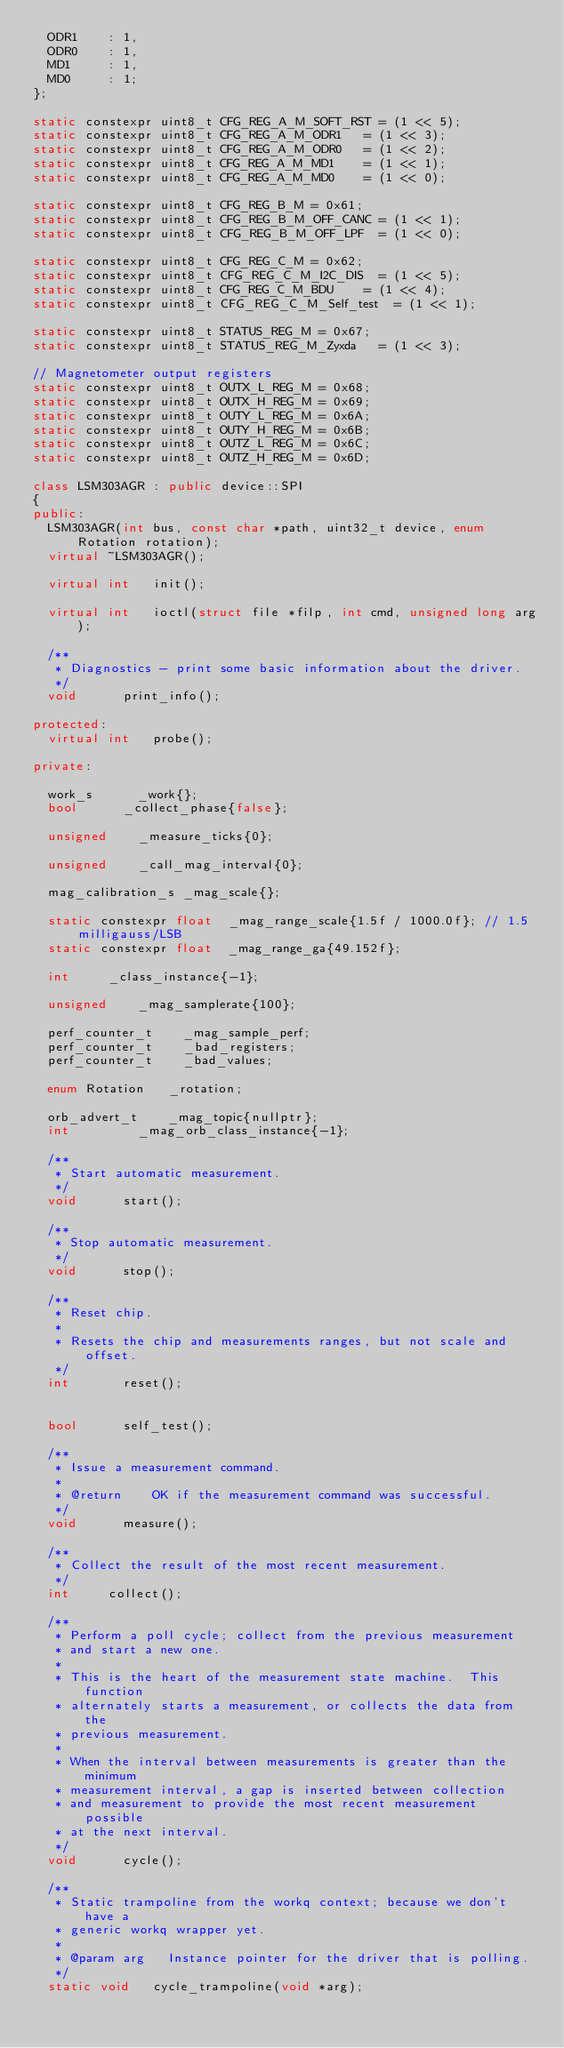Convert code to text. <code><loc_0><loc_0><loc_500><loc_500><_C++_>	ODR1		: 1,
	ODR0		: 1,
	MD1			: 1,
	MD0			: 1;
};

static constexpr uint8_t CFG_REG_A_M_SOFT_RST	= (1 << 5);
static constexpr uint8_t CFG_REG_A_M_ODR1		= (1 << 3);
static constexpr uint8_t CFG_REG_A_M_ODR0		= (1 << 2);
static constexpr uint8_t CFG_REG_A_M_MD1		= (1 << 1);
static constexpr uint8_t CFG_REG_A_M_MD0		= (1 << 0);

static constexpr uint8_t CFG_REG_B_M = 0x61;
static constexpr uint8_t CFG_REG_B_M_OFF_CANC	= (1 << 1);
static constexpr uint8_t CFG_REG_B_M_OFF_LPF	= (1 << 0);

static constexpr uint8_t CFG_REG_C_M = 0x62;
static constexpr uint8_t CFG_REG_C_M_I2C_DIS	= (1 << 5);
static constexpr uint8_t CFG_REG_C_M_BDU		= (1 << 4);
static constexpr uint8_t CFG_REG_C_M_Self_test	= (1 << 1);

static constexpr uint8_t STATUS_REG_M = 0x67;
static constexpr uint8_t STATUS_REG_M_Zyxda		= (1 << 3);

// Magnetometer output registers
static constexpr uint8_t OUTX_L_REG_M = 0x68;
static constexpr uint8_t OUTX_H_REG_M = 0x69;
static constexpr uint8_t OUTY_L_REG_M = 0x6A;
static constexpr uint8_t OUTY_H_REG_M = 0x6B;
static constexpr uint8_t OUTZ_L_REG_M = 0x6C;
static constexpr uint8_t OUTZ_H_REG_M = 0x6D;

class LSM303AGR : public device::SPI
{
public:
	LSM303AGR(int bus, const char *path, uint32_t device, enum Rotation rotation);
	virtual ~LSM303AGR();

	virtual int		init();

	virtual int		ioctl(struct file *filp, int cmd, unsigned long arg);

	/**
	 * Diagnostics - print some basic information about the driver.
	 */
	void			print_info();

protected:
	virtual int		probe();

private:

	work_s			_work{};
	bool			_collect_phase{false};

	unsigned		_measure_ticks{0};

	unsigned		_call_mag_interval{0};

	mag_calibration_s	_mag_scale{};

	static constexpr float	_mag_range_scale{1.5f / 1000.0f}; // 1.5 milligauss/LSB
	static constexpr float	_mag_range_ga{49.152f};

	int			_class_instance{-1};

	unsigned		_mag_samplerate{100};

	perf_counter_t		_mag_sample_perf;
	perf_counter_t		_bad_registers;
	perf_counter_t		_bad_values;

	enum Rotation		_rotation;

	orb_advert_t		_mag_topic{nullptr};
	int					_mag_orb_class_instance{-1};

	/**
	 * Start automatic measurement.
	 */
	void			start();

	/**
	 * Stop automatic measurement.
	 */
	void			stop();

	/**
	 * Reset chip.
	 *
	 * Resets the chip and measurements ranges, but not scale and offset.
	 */
	int				reset();


	bool			self_test();

	/**
	 * Issue a measurement command.
	 *
	 * @return		OK if the measurement command was successful.
	 */
	void			measure();

	/**
	 * Collect the result of the most recent measurement.
	 */
	int			collect();

	/**
	 * Perform a poll cycle; collect from the previous measurement
	 * and start a new one.
	 *
	 * This is the heart of the measurement state machine.  This function
	 * alternately starts a measurement, or collects the data from the
	 * previous measurement.
	 *
	 * When the interval between measurements is greater than the minimum
	 * measurement interval, a gap is inserted between collection
	 * and measurement to provide the most recent measurement possible
	 * at the next interval.
	 */
	void			cycle();

	/**
	 * Static trampoline from the workq context; because we don't have a
	 * generic workq wrapper yet.
	 *
	 * @param arg		Instance pointer for the driver that is polling.
	 */
	static void		cycle_trampoline(void *arg);</code> 